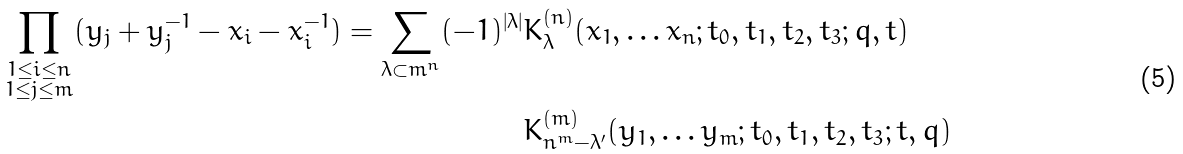<formula> <loc_0><loc_0><loc_500><loc_500>\prod _ { \substack { 1 \leq i \leq n \\ 1 \leq j \leq m } } ( y _ { j } + y _ { j } ^ { - 1 } - x _ { i } - x _ { i } ^ { - 1 } ) = \sum _ { \lambda \subset m ^ { n } } ( - 1 ) ^ { | \lambda | } & K ^ { ( n ) } _ { \lambda } ( x _ { 1 } , \dots x _ { n } ; t _ { 0 } , t _ { 1 } , t _ { 2 } , t _ { 3 } ; q , t ) \\ & K ^ { ( m ) } _ { n ^ { m } - \lambda ^ { \prime } } ( y _ { 1 } , \dots y _ { m } ; t _ { 0 } , t _ { 1 } , t _ { 2 } , t _ { 3 } ; t , q )</formula> 